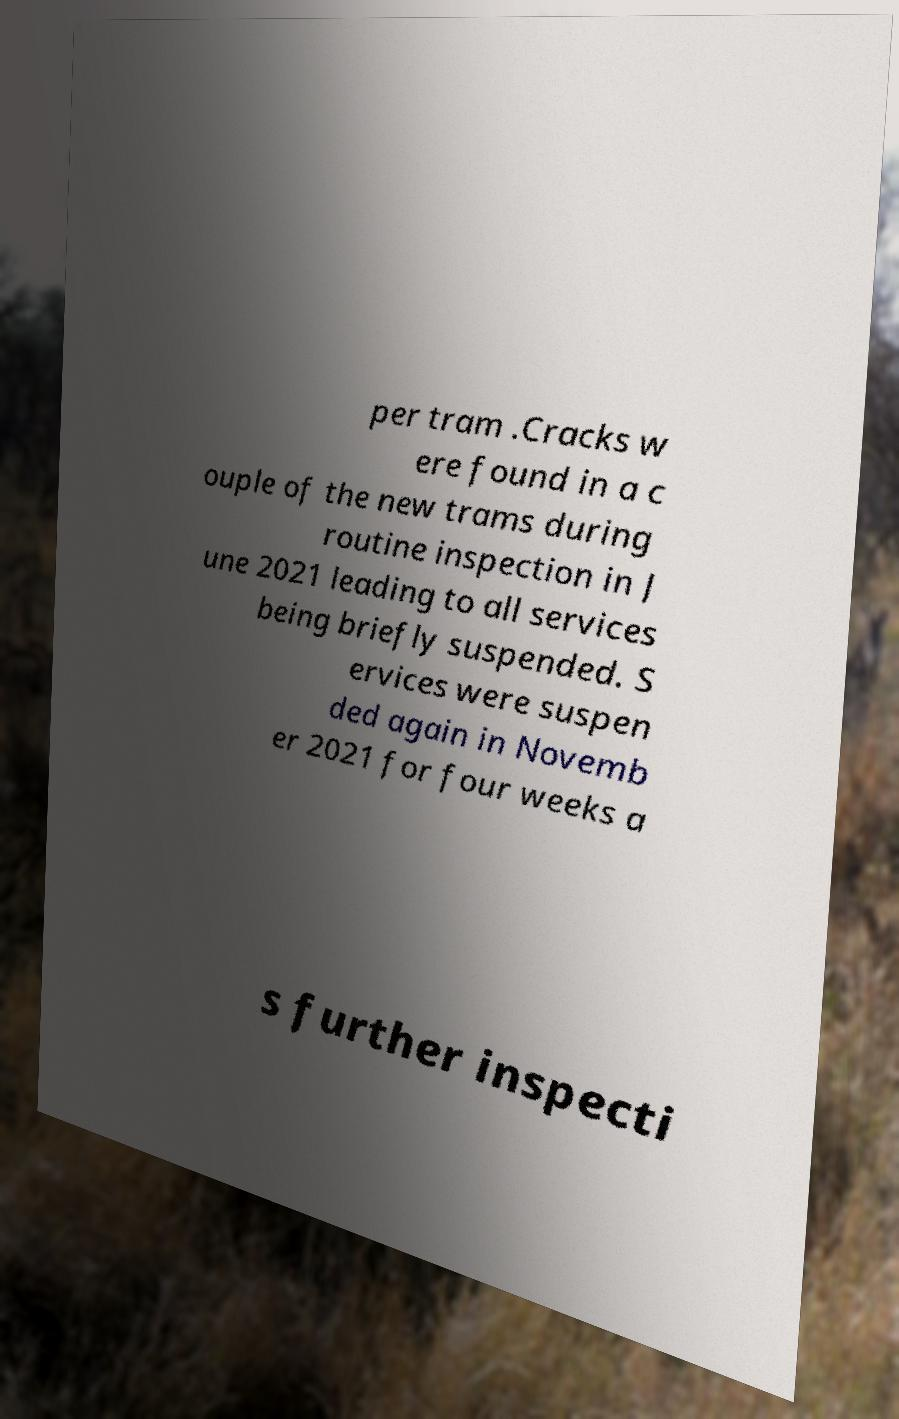I need the written content from this picture converted into text. Can you do that? per tram .Cracks w ere found in a c ouple of the new trams during routine inspection in J une 2021 leading to all services being briefly suspended. S ervices were suspen ded again in Novemb er 2021 for four weeks a s further inspecti 